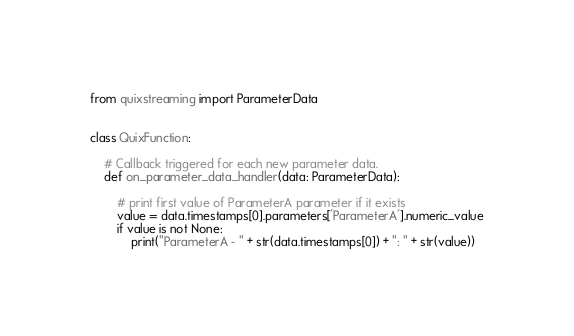Convert code to text. <code><loc_0><loc_0><loc_500><loc_500><_Python_>from quixstreaming import ParameterData


class QuixFunction:

    # Callback triggered for each new parameter data.
    def on_parameter_data_handler(data: ParameterData):

        # print first value of ParameterA parameter if it exists
        value = data.timestamps[0].parameters['ParameterA'].numeric_value
        if value is not None:
            print("ParameterA - " + str(data.timestamps[0]) + ": " + str(value))

</code> 